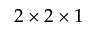<formula> <loc_0><loc_0><loc_500><loc_500>2 \times 2 \times 1</formula> 